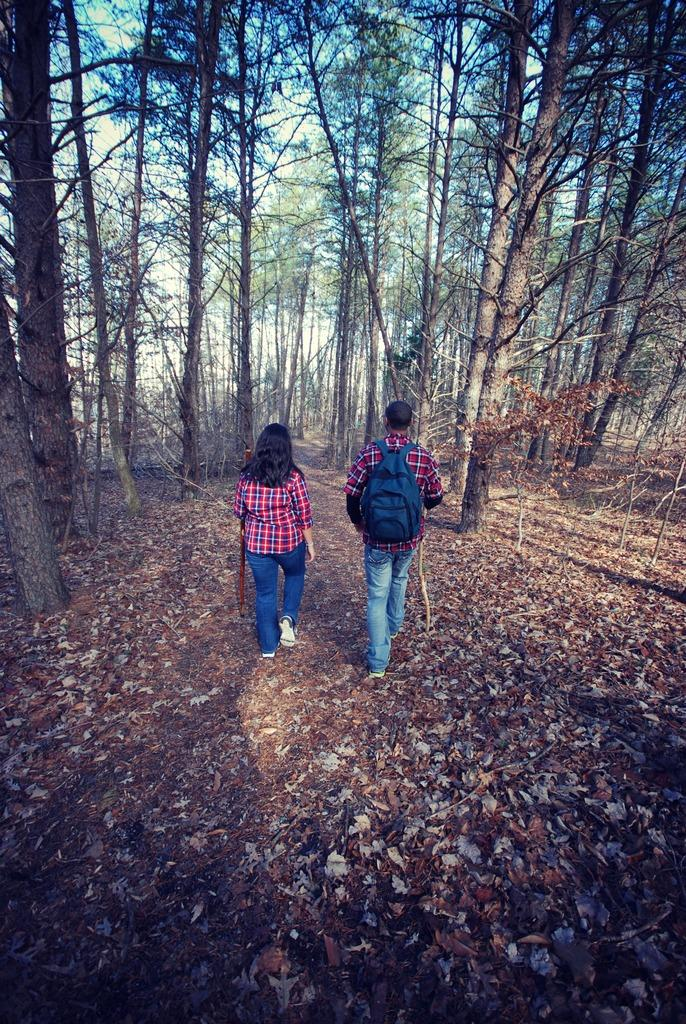How many people are present in the image? There are two persons standing in the image. Can you describe what one of the persons is wearing? One of the persons is wearing a bag. What can be seen in the background of the image? There are trees and the sky visible in the background of the image. What type of board is being used by the person in the image? There is no board present in the image. Can you tell me how the cable is connected to the person in the image? There is no cable present in the image. 